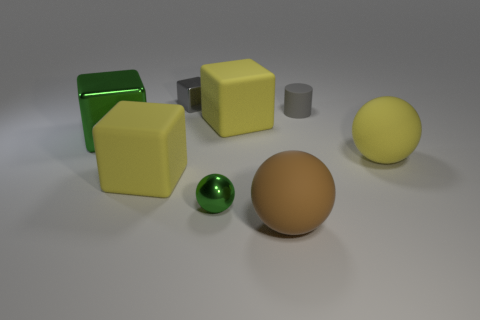How many green objects are large cubes or tiny metallic blocks?
Provide a short and direct response. 1. How many small shiny blocks are the same color as the small cylinder?
Your answer should be very brief. 1. Is the material of the yellow sphere the same as the green ball?
Your response must be concise. No. There is a metal object behind the green cube; how many gray objects are in front of it?
Your answer should be compact. 1. Does the cylinder have the same size as the brown matte object?
Provide a succinct answer. No. What number of green balls are made of the same material as the big green block?
Offer a terse response. 1. There is a yellow matte thing that is the same shape as the tiny green thing; what is its size?
Offer a terse response. Large. Does the small thing in front of the tiny gray matte cylinder have the same shape as the large brown matte object?
Provide a succinct answer. Yes. The small gray metal object that is behind the green object in front of the big green block is what shape?
Ensure brevity in your answer.  Cube. Is there any other thing that has the same shape as the tiny gray matte thing?
Your response must be concise. No. 